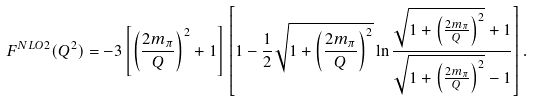Convert formula to latex. <formula><loc_0><loc_0><loc_500><loc_500>F ^ { N L O 2 } ( Q ^ { 2 } ) = - 3 \left [ \left ( \frac { 2 m _ { \pi } } { Q } \right ) ^ { 2 } + 1 \right ] \left [ 1 - \frac { 1 } { 2 } \sqrt { 1 + \left ( \frac { 2 m _ { \pi } } { Q } \right ) ^ { 2 } } \ln \frac { \sqrt { 1 + \left ( \frac { 2 m _ { \pi } } { Q } \right ) ^ { 2 } } + 1 } { \sqrt { 1 + \left ( \frac { 2 m _ { \pi } } { Q } \right ) ^ { 2 } } - 1 } \right ] .</formula> 